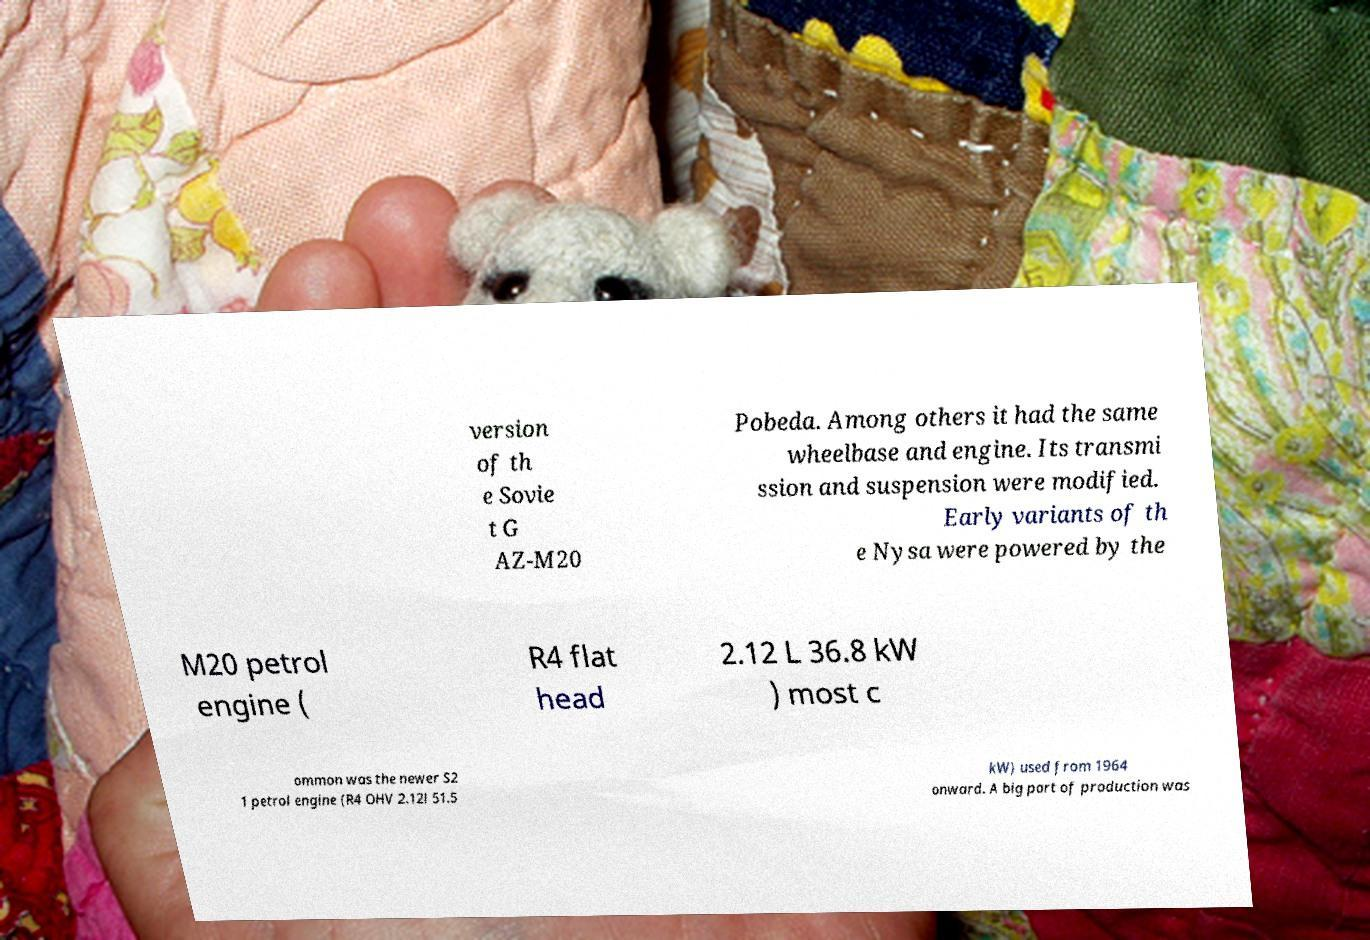Can you read and provide the text displayed in the image?This photo seems to have some interesting text. Can you extract and type it out for me? version of th e Sovie t G AZ-M20 Pobeda. Among others it had the same wheelbase and engine. Its transmi ssion and suspension were modified. Early variants of th e Nysa were powered by the M20 petrol engine ( R4 flat head 2.12 L 36.8 kW ) most c ommon was the newer S2 1 petrol engine (R4 OHV 2.12l 51.5 kW) used from 1964 onward. A big part of production was 